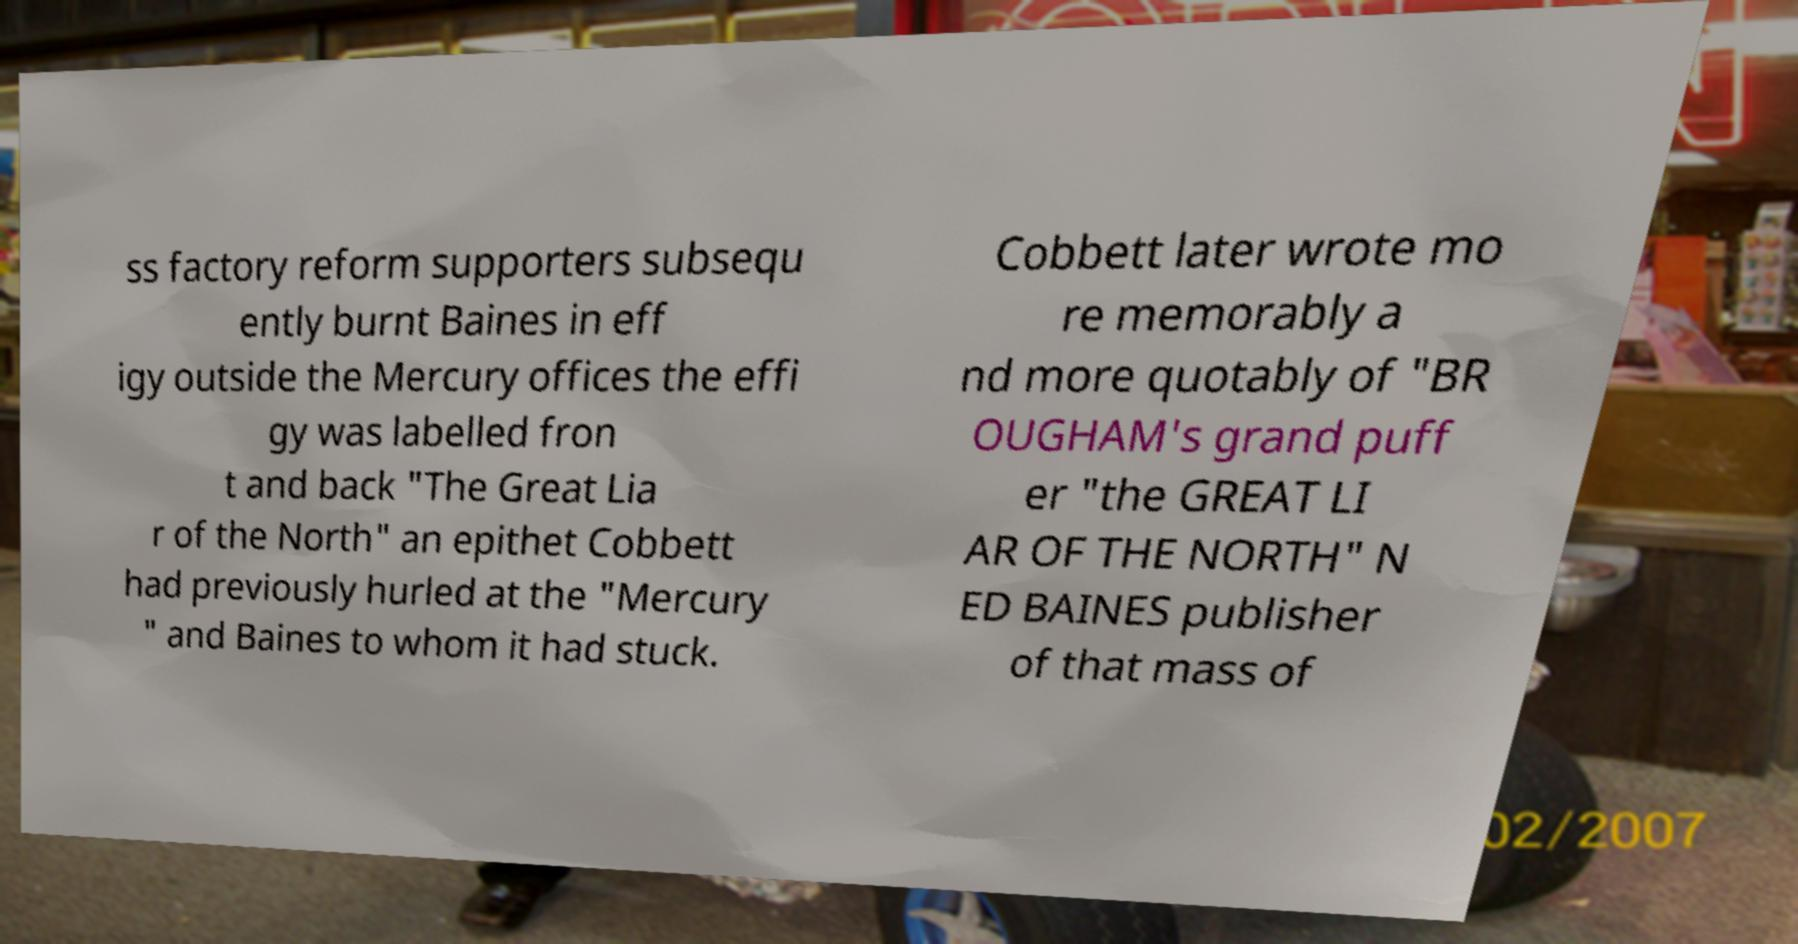What messages or text are displayed in this image? I need them in a readable, typed format. ss factory reform supporters subsequ ently burnt Baines in eff igy outside the Mercury offices the effi gy was labelled fron t and back "The Great Lia r of the North" an epithet Cobbett had previously hurled at the "Mercury " and Baines to whom it had stuck. Cobbett later wrote mo re memorably a nd more quotably of "BR OUGHAM's grand puff er "the GREAT LI AR OF THE NORTH" N ED BAINES publisher of that mass of 